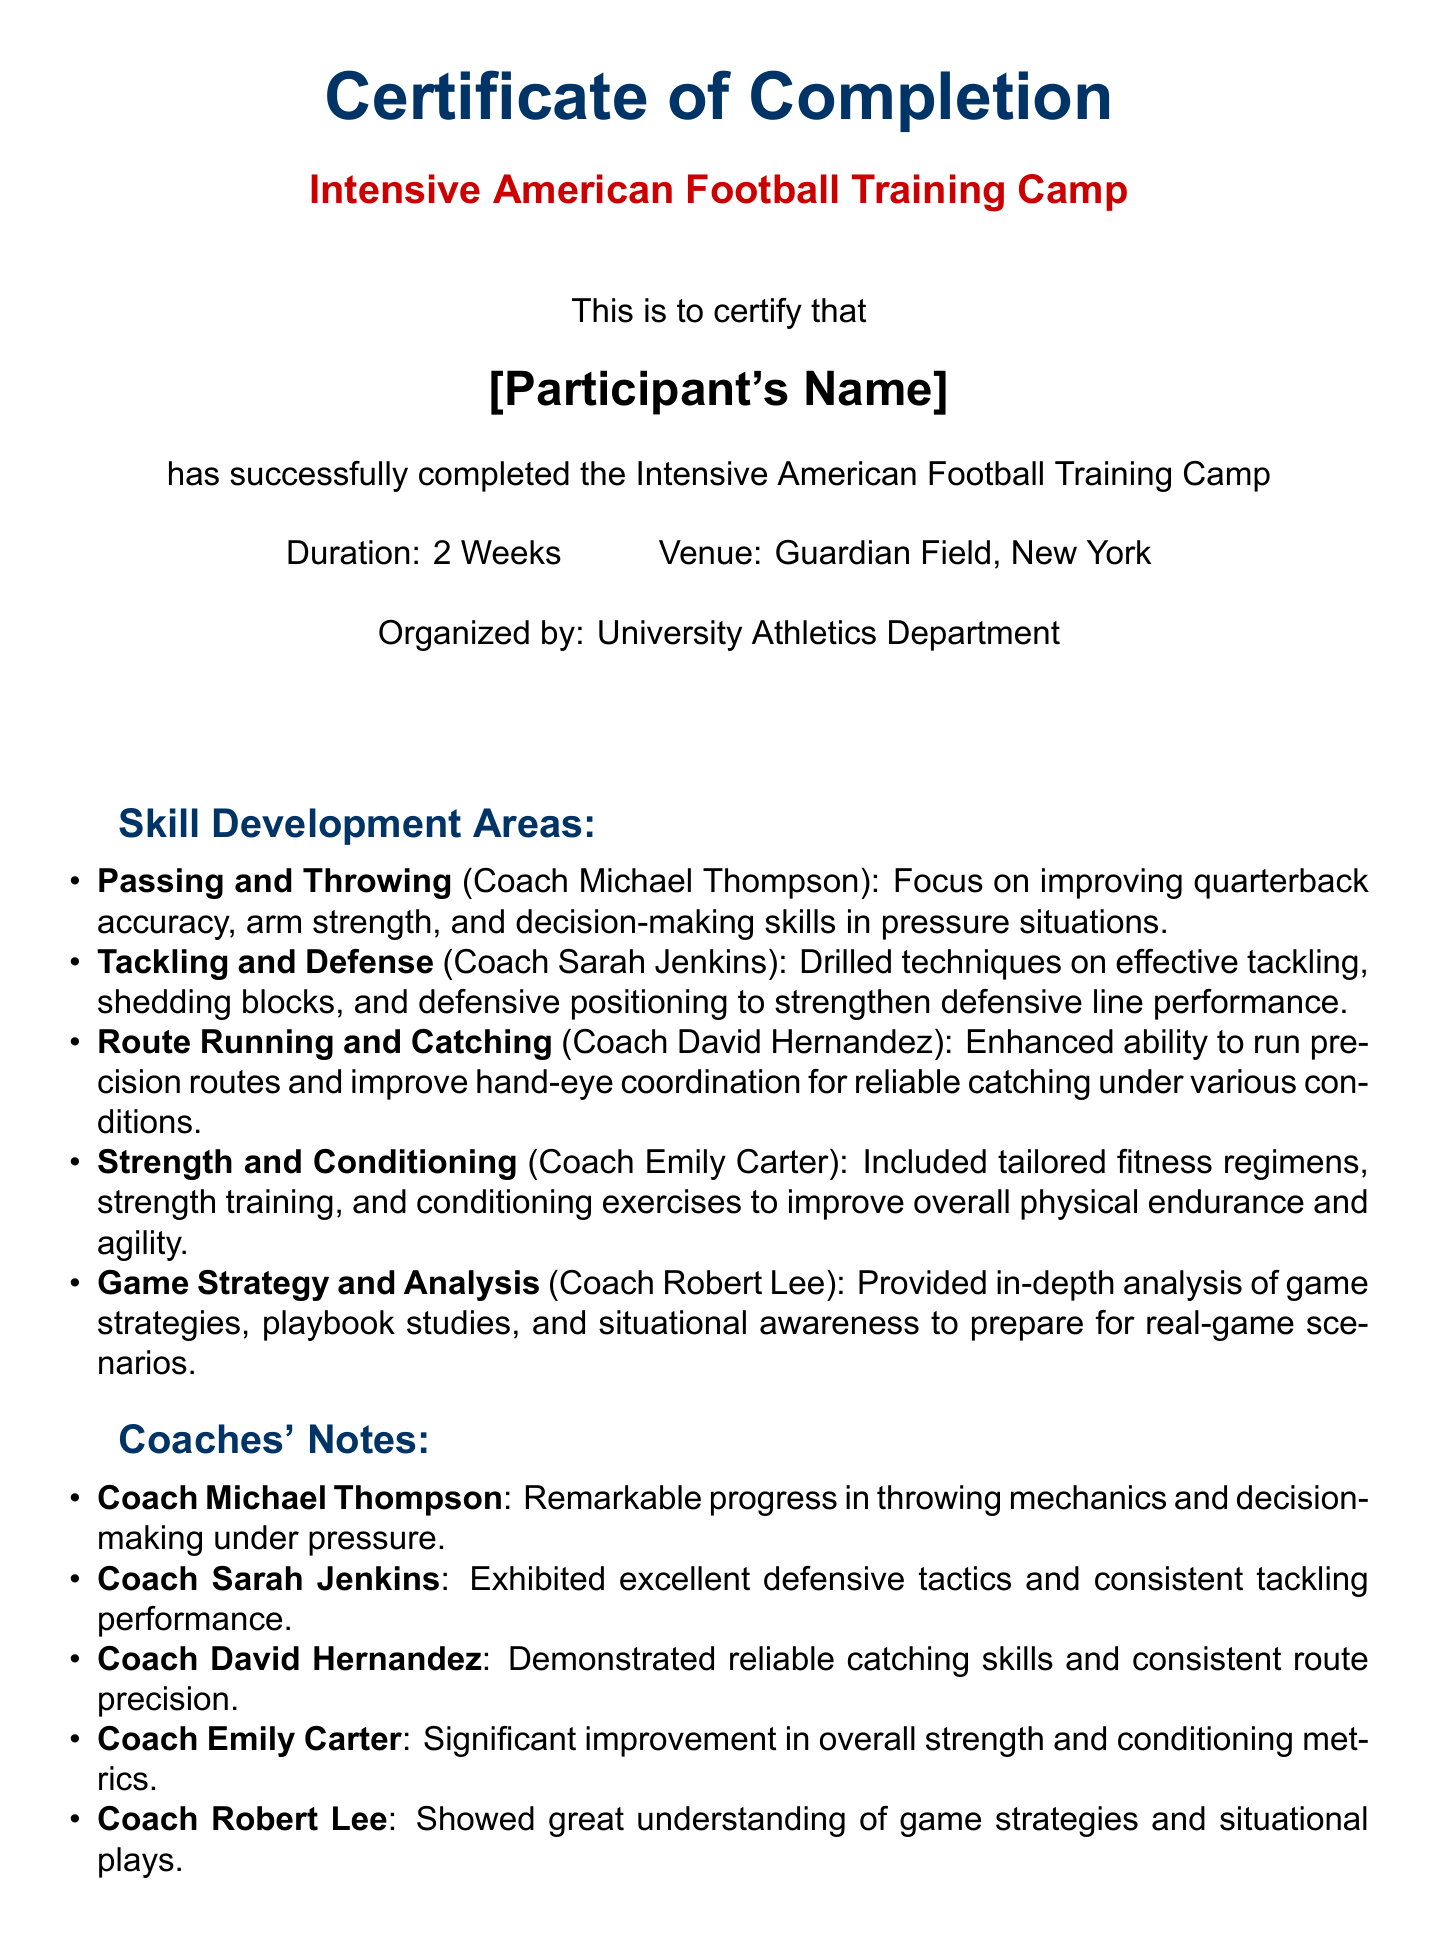What is the duration of the training camp? The document specifies that the training camp lasted a duration of 2 weeks.
Answer: 2 Weeks Where was the training camp held? The venue for the training camp is stated as Guardian Field, New York.
Answer: Guardian Field, New York Who organized the training camp? The organizing body for the camp is identified as the University Athletics Department.
Answer: University Athletics Department What skill area does Coach Sarah Jenkins specialize in? The skill development area associated with Coach Sarah Jenkins is Tackling and Defense.
Answer: Tackling and Defense What notable improvement was mentioned by Coach Michael Thompson? Coach Michael Thompson noted remarkable progress in throwing mechanics and decision-making under pressure.
Answer: Remarkable progress in throwing mechanics and decision-making under pressure How many skill development areas are listed in the document? The document outlines five distinct skill development areas covered during the training camp.
Answer: 5 Who is the Director of Athletics as indicated in the document? The document has a placeholder for the representative's name, indicating the Director of Athletics.
Answer: [Representative's Name] What is one aspect of the training that Coach Emily Carter focused on? Coach Emily Carter focused on strength training as part of the skill development areas.
Answer: Strength training What type of document is this? The document is a Certificate of Completion for a training camp.
Answer: Certificate of Completion 